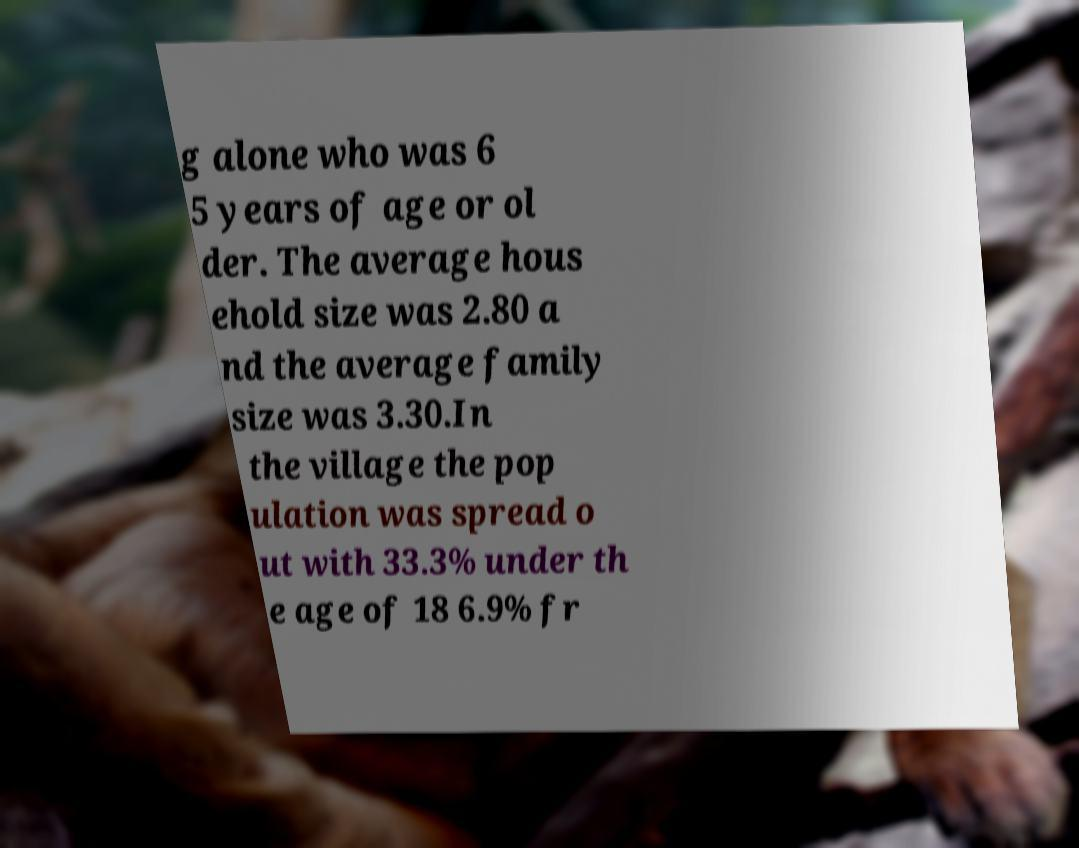Can you read and provide the text displayed in the image?This photo seems to have some interesting text. Can you extract and type it out for me? g alone who was 6 5 years of age or ol der. The average hous ehold size was 2.80 a nd the average family size was 3.30.In the village the pop ulation was spread o ut with 33.3% under th e age of 18 6.9% fr 